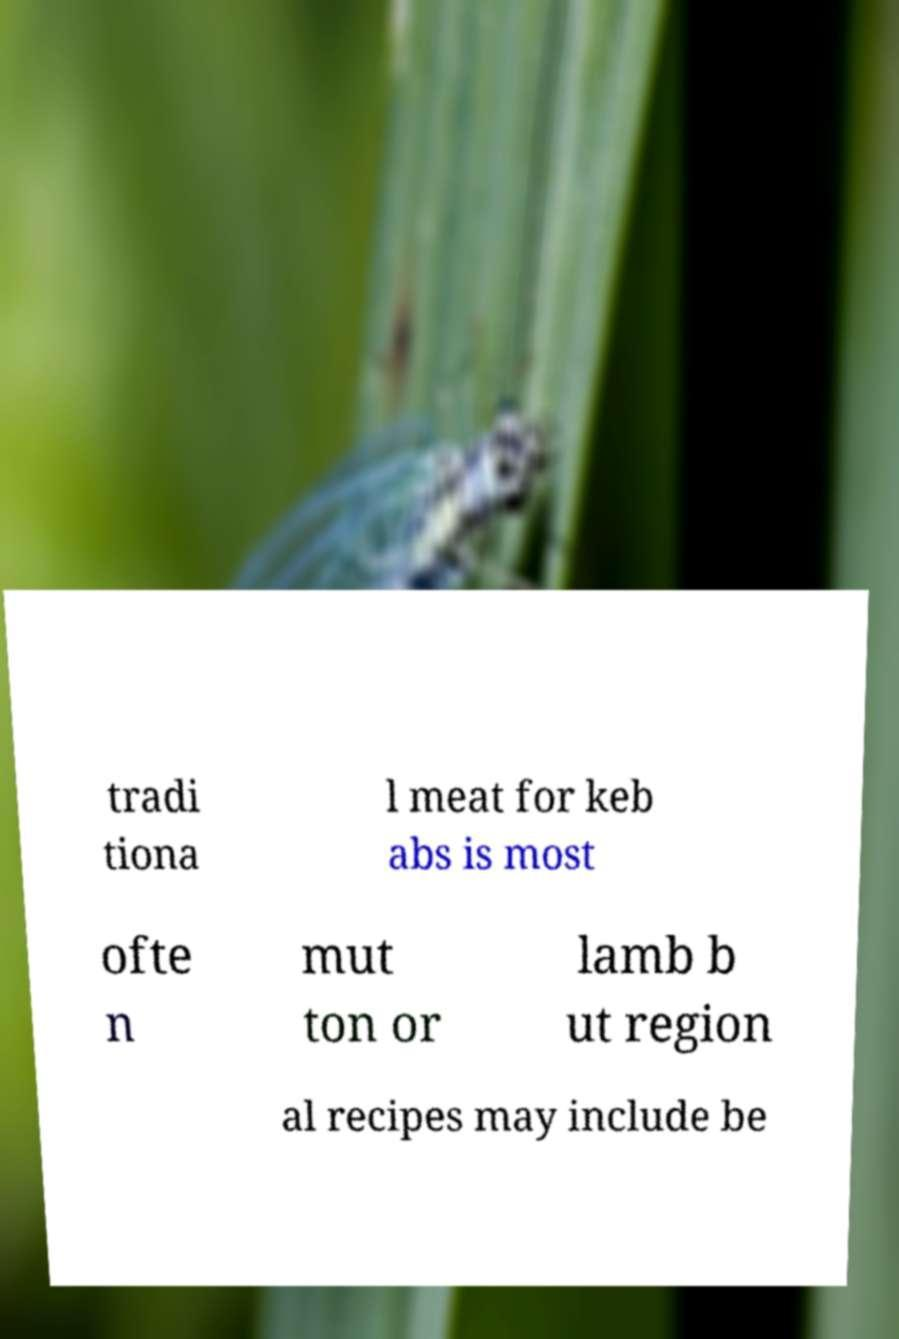Can you read and provide the text displayed in the image?This photo seems to have some interesting text. Can you extract and type it out for me? tradi tiona l meat for keb abs is most ofte n mut ton or lamb b ut region al recipes may include be 